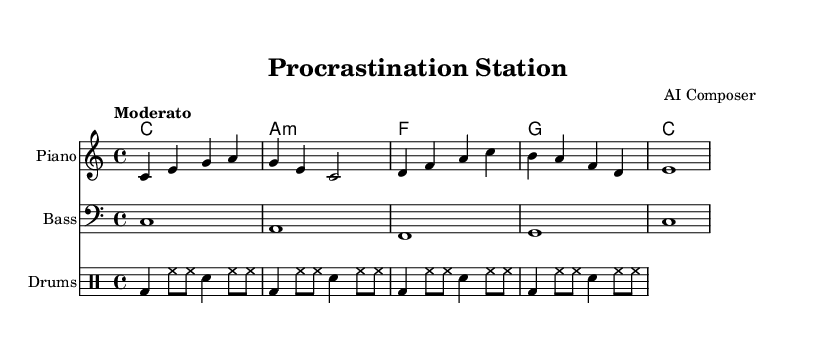What is the key signature of this music? The key signature is C major, which has no sharps or flats.
Answer: C major What is the time signature of this music? The time signature indicates that there are four beats in each measure as it is written as 4/4.
Answer: 4/4 What is the tempo marking for this piece? The tempo marking is "Moderato," which suggests a moderate speed.
Answer: Moderato How many measures does the melody have? By counting the measures in the melody section, there are 5 measures visible.
Answer: 5 What type of chords are used in the harmony section? The harmony section contains a mix of major and minor chords, evident in the progression listed.
Answer: Major and minor Explain the relation between the melody and bass in the first measure. The melody starts on the note C, and the bass also plays C in the first measure, creating a strong foundational tone. This unison gives harmonic support.
Answer: Both play C What instrument is indicated for the drum part? The drum part is labeled under a specific staff named "Drums," showing that it’s a drum accompaniment.
Answer: Drums 